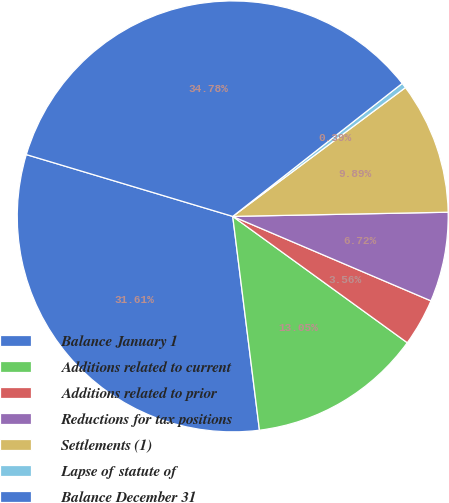Convert chart to OTSL. <chart><loc_0><loc_0><loc_500><loc_500><pie_chart><fcel>Balance January 1<fcel>Additions related to current<fcel>Additions related to prior<fcel>Reductions for tax positions<fcel>Settlements (1)<fcel>Lapse of statute of<fcel>Balance December 31<nl><fcel>31.61%<fcel>13.05%<fcel>3.56%<fcel>6.72%<fcel>9.89%<fcel>0.39%<fcel>34.78%<nl></chart> 